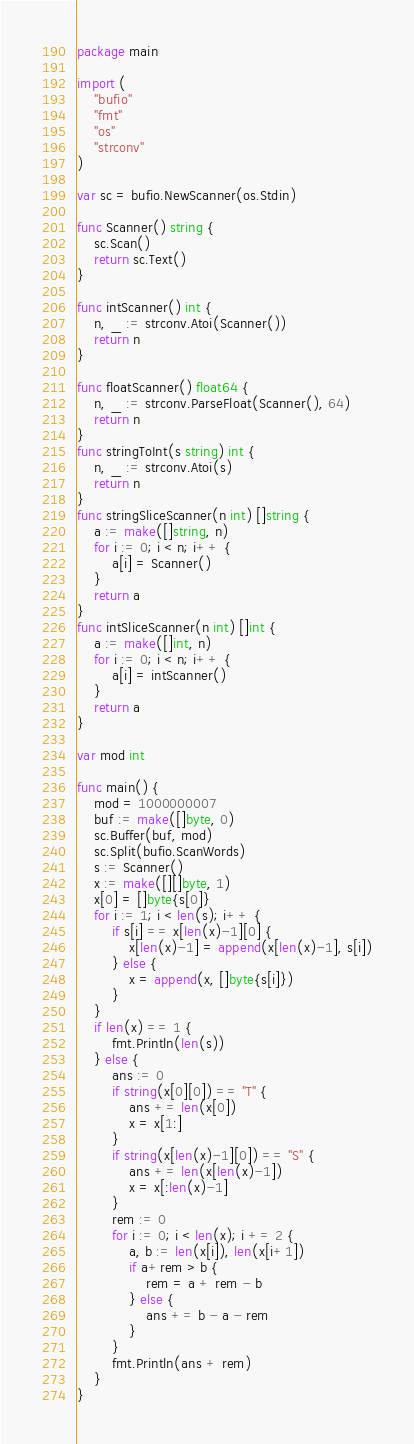<code> <loc_0><loc_0><loc_500><loc_500><_Go_>package main

import (
	"bufio"
	"fmt"
	"os"
	"strconv"
)

var sc = bufio.NewScanner(os.Stdin)

func Scanner() string {
	sc.Scan()
	return sc.Text()
}

func intScanner() int {
	n, _ := strconv.Atoi(Scanner())
	return n
}

func floatScanner() float64 {
	n, _ := strconv.ParseFloat(Scanner(), 64)
	return n
}
func stringToInt(s string) int {
	n, _ := strconv.Atoi(s)
	return n
}
func stringSliceScanner(n int) []string {
	a := make([]string, n)
	for i := 0; i < n; i++ {
		a[i] = Scanner()
	}
	return a
}
func intSliceScanner(n int) []int {
	a := make([]int, n)
	for i := 0; i < n; i++ {
		a[i] = intScanner()
	}
	return a
}

var mod int

func main() {
	mod = 1000000007
	buf := make([]byte, 0)
	sc.Buffer(buf, mod)
	sc.Split(bufio.ScanWords)
	s := Scanner()
	x := make([][]byte, 1)
	x[0] = []byte{s[0]}
	for i := 1; i < len(s); i++ {
		if s[i] == x[len(x)-1][0] {
			x[len(x)-1] = append(x[len(x)-1], s[i])
		} else {
			x = append(x, []byte{s[i]})
		}
	}
	if len(x) == 1 {
		fmt.Println(len(s))
	} else {
		ans := 0
		if string(x[0][0]) == "T" {
			ans += len(x[0])
			x = x[1:]
		}
		if string(x[len(x)-1][0]) == "S" {
			ans += len(x[len(x)-1])
			x = x[:len(x)-1]
		}
		rem := 0
		for i := 0; i < len(x); i += 2 {
			a, b := len(x[i]), len(x[i+1])
			if a+rem > b {
				rem = a + rem - b
			} else {
				ans += b - a - rem
			}
		}
		fmt.Println(ans + rem)
	}
}
</code> 